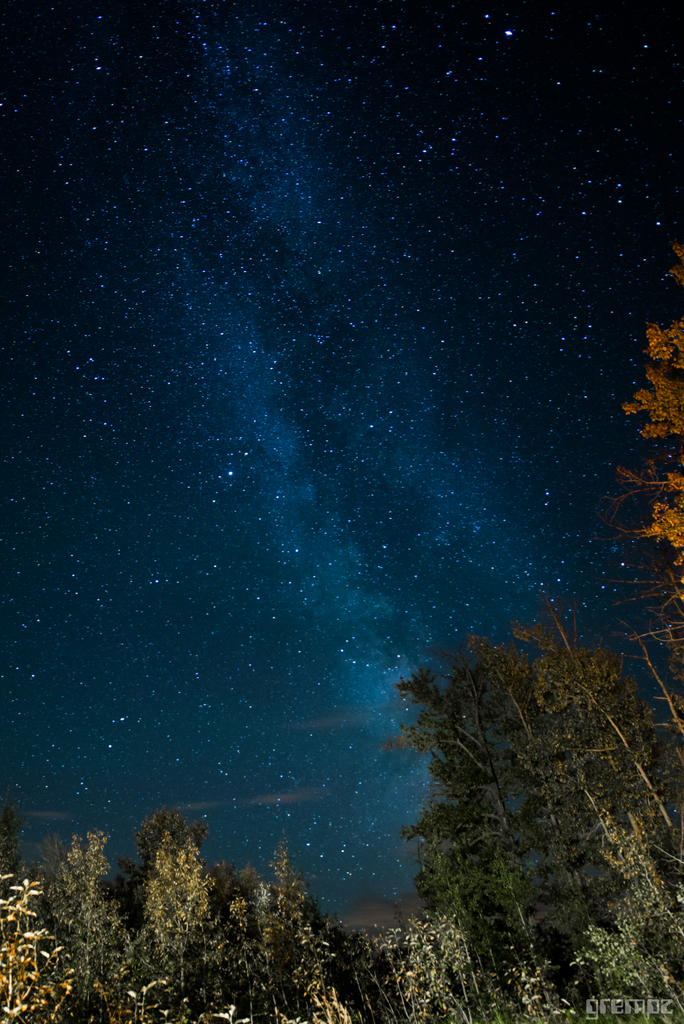What are the bright little specks and what causes them to be bright? The bright little specks are stars. They are bright because they are balls of hot gas that emit their own light. The light from stars travels through space and reaches our eyes, making them appear bright. 